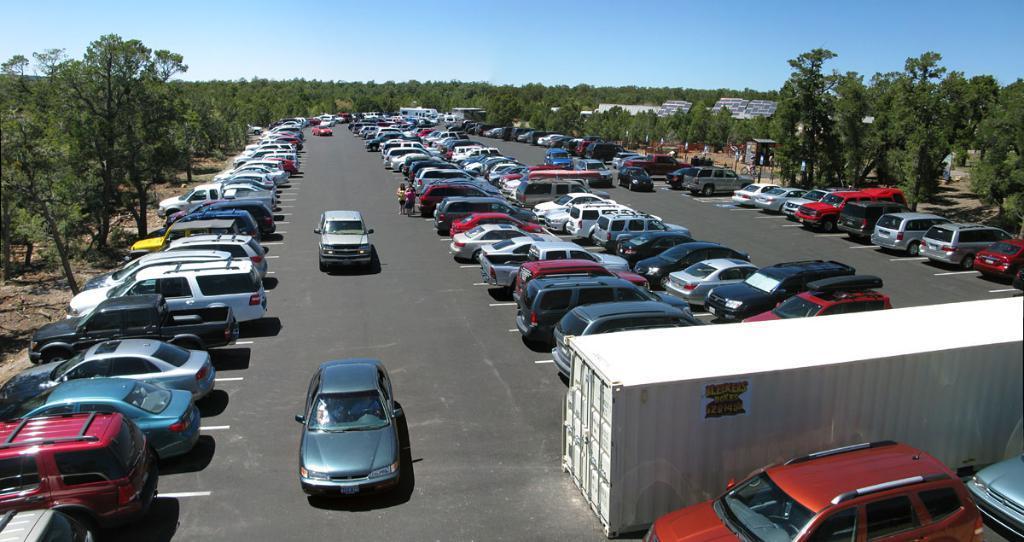Please provide a concise description of this image. In this image there are cars on the road. There is a container with a poster on it. There are buildings, trees and boards. At the top of the image there is sky. 